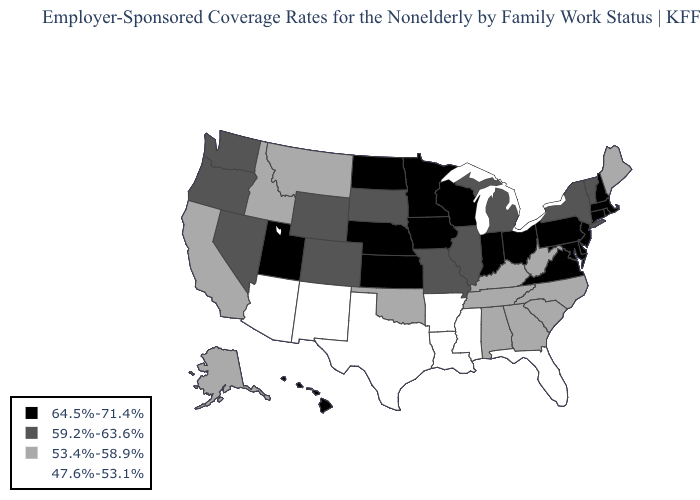Name the states that have a value in the range 59.2%-63.6%?
Answer briefly. Colorado, Illinois, Michigan, Missouri, Nevada, New York, Oregon, South Dakota, Vermont, Washington, Wyoming. Does the first symbol in the legend represent the smallest category?
Be succinct. No. Does Massachusetts have the lowest value in the USA?
Keep it brief. No. Does Alaska have the highest value in the West?
Keep it brief. No. What is the value of Vermont?
Write a very short answer. 59.2%-63.6%. What is the value of Ohio?
Answer briefly. 64.5%-71.4%. Name the states that have a value in the range 64.5%-71.4%?
Write a very short answer. Connecticut, Delaware, Hawaii, Indiana, Iowa, Kansas, Maryland, Massachusetts, Minnesota, Nebraska, New Hampshire, New Jersey, North Dakota, Ohio, Pennsylvania, Rhode Island, Utah, Virginia, Wisconsin. Among the states that border Illinois , which have the lowest value?
Be succinct. Kentucky. Does California have a lower value than Utah?
Answer briefly. Yes. Is the legend a continuous bar?
Give a very brief answer. No. What is the value of Georgia?
Short answer required. 53.4%-58.9%. Among the states that border Iowa , does Missouri have the lowest value?
Quick response, please. Yes. Name the states that have a value in the range 64.5%-71.4%?
Concise answer only. Connecticut, Delaware, Hawaii, Indiana, Iowa, Kansas, Maryland, Massachusetts, Minnesota, Nebraska, New Hampshire, New Jersey, North Dakota, Ohio, Pennsylvania, Rhode Island, Utah, Virginia, Wisconsin. What is the value of Alabama?
Quick response, please. 53.4%-58.9%. Name the states that have a value in the range 53.4%-58.9%?
Answer briefly. Alabama, Alaska, California, Georgia, Idaho, Kentucky, Maine, Montana, North Carolina, Oklahoma, South Carolina, Tennessee, West Virginia. 